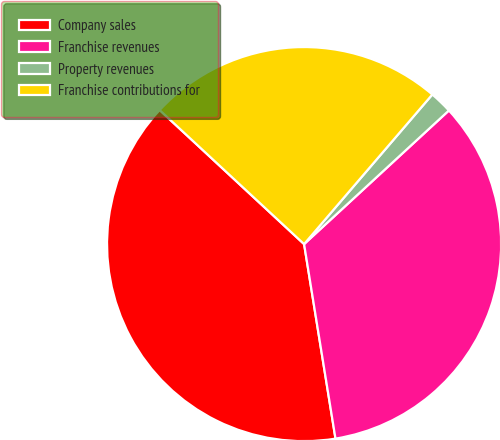Convert chart to OTSL. <chart><loc_0><loc_0><loc_500><loc_500><pie_chart><fcel>Company sales<fcel>Franchise revenues<fcel>Property revenues<fcel>Franchise contributions for<nl><fcel>39.45%<fcel>34.31%<fcel>1.86%<fcel>24.37%<nl></chart> 